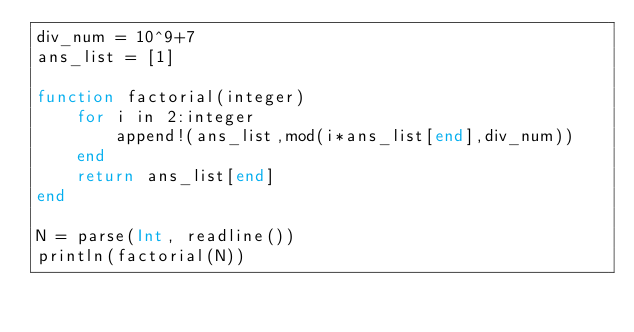Convert code to text. <code><loc_0><loc_0><loc_500><loc_500><_Julia_>div_num = 10^9+7
ans_list = [1]

function factorial(integer)
    for i in 2:integer
        append!(ans_list,mod(i*ans_list[end],div_num))
    end
    return ans_list[end]
end

N = parse(Int, readline())
println(factorial(N))</code> 